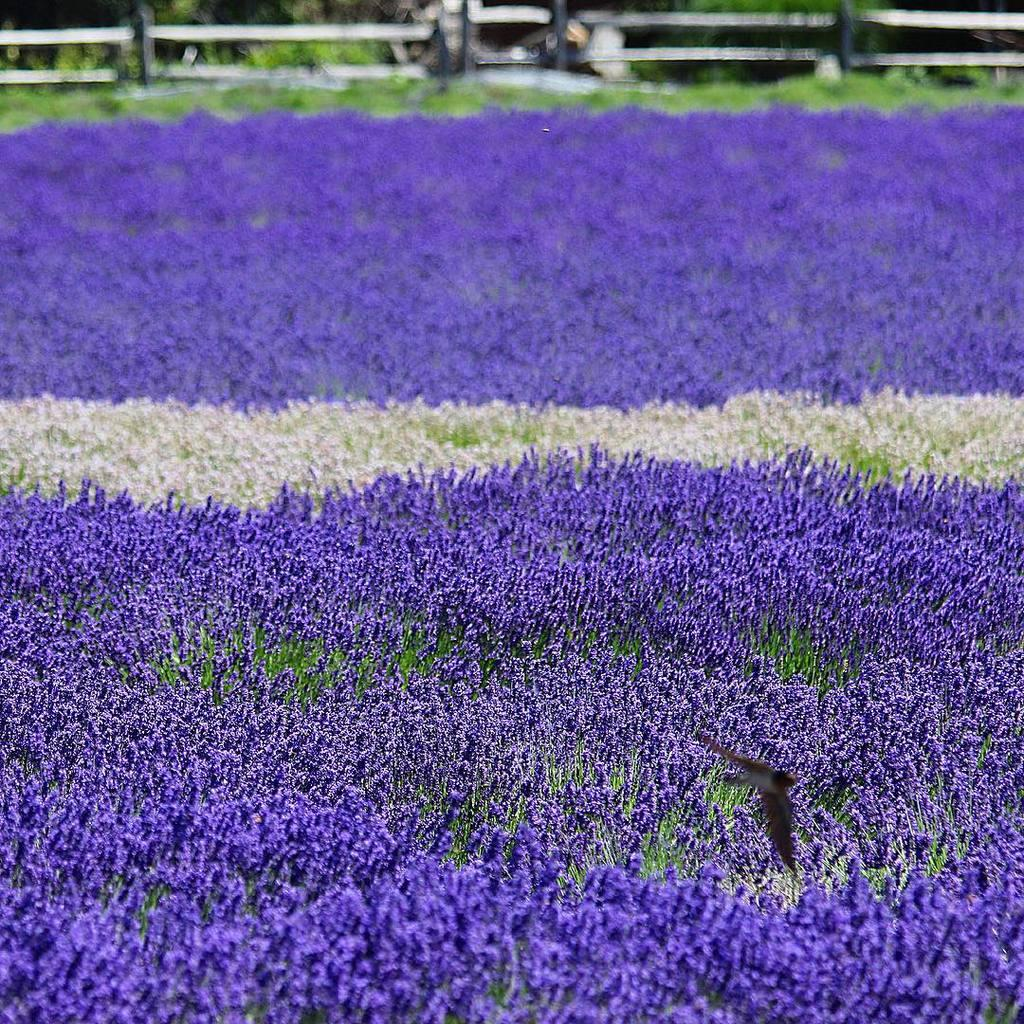What colors are the flowers in the image? The flowers in the image are violet and white. What is located at the top of the image? There is a fencing at the top of the image. What type of vegetation can be seen in the image? There are trees in the image. How many waves can be seen crashing on the shore in the image? There are no waves present in the image; it features flowers, fencing, and trees. What type of animals are roaming around the flowers in the image? There are no animals, specifically chickens, present in the image. 